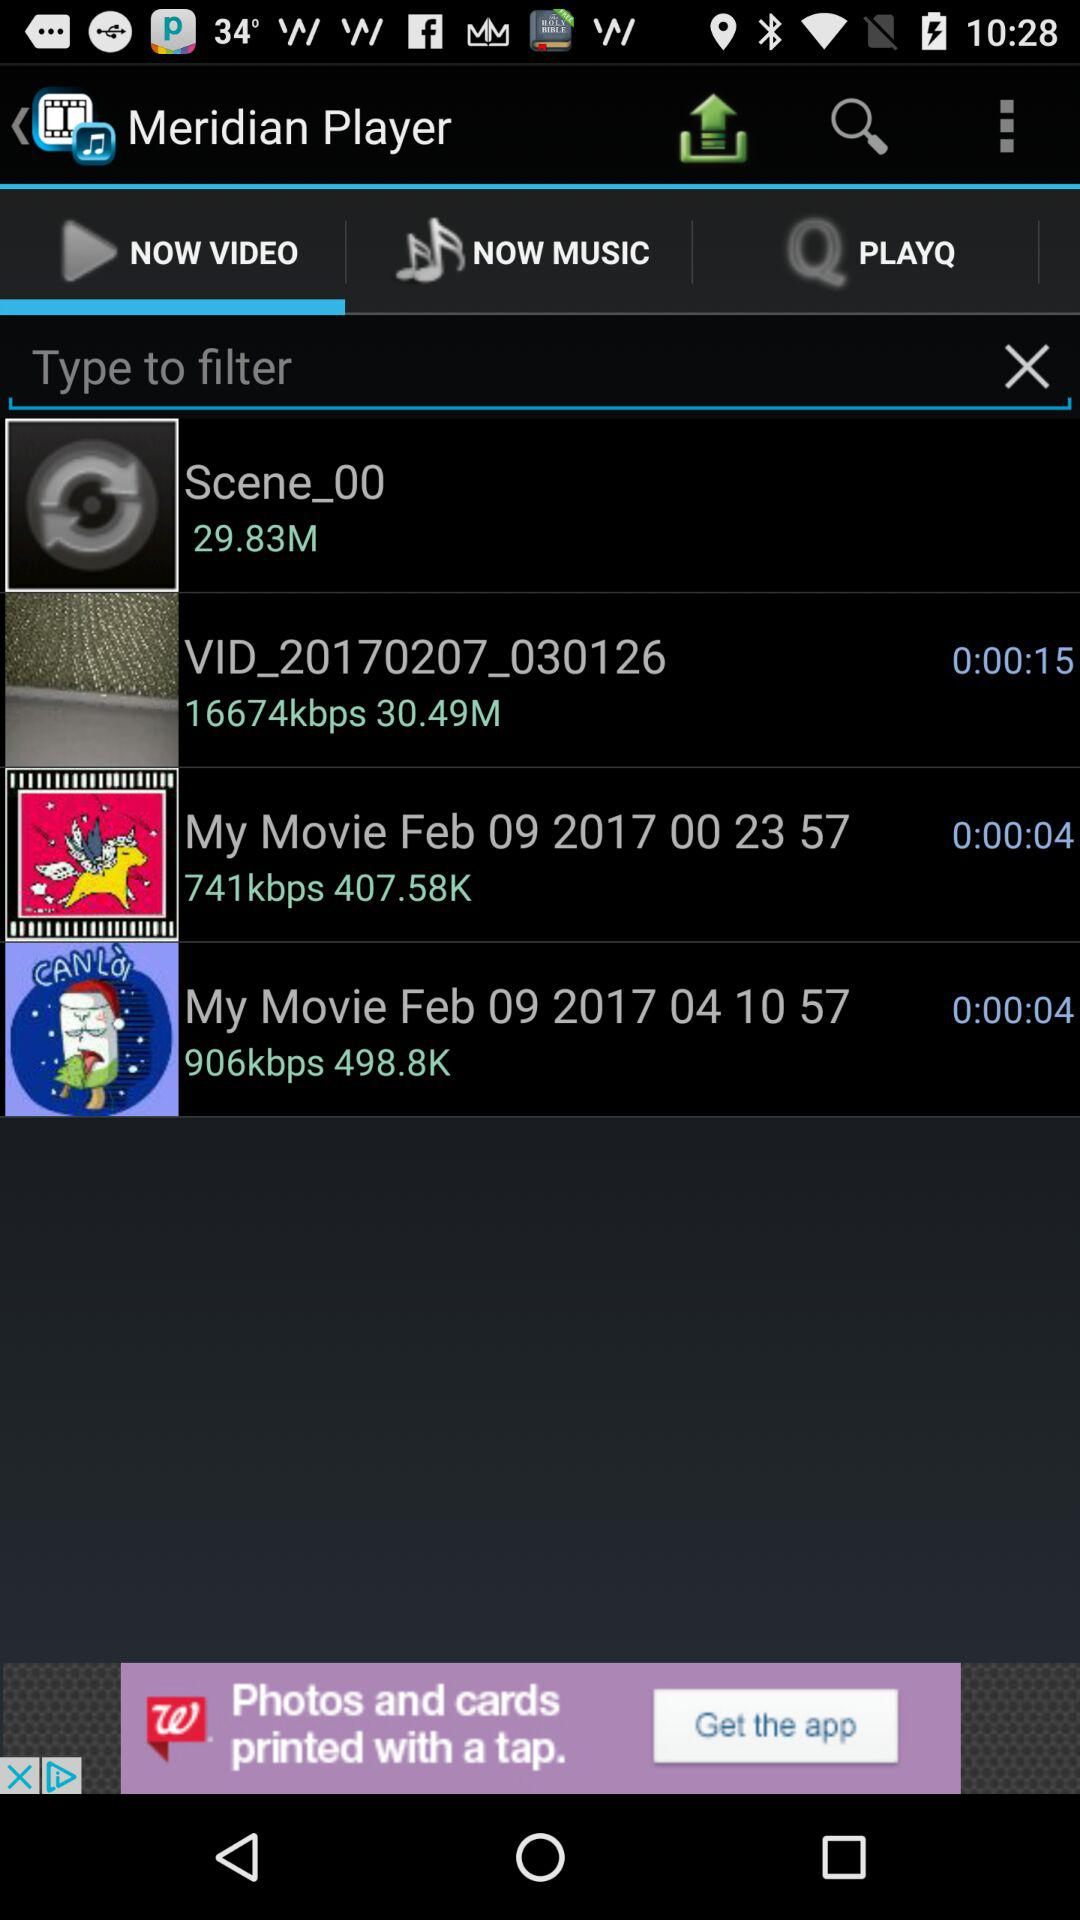What is the name of the video with the duration of 0:00:15? The name of the video is "VID_20170207_030126". 